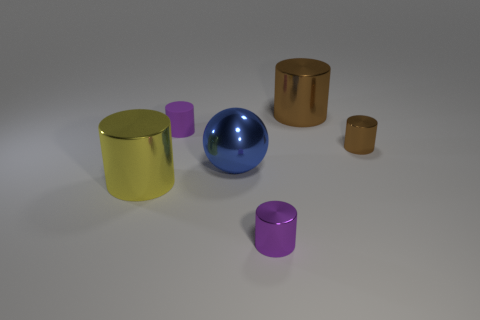Subtract all purple shiny cylinders. How many cylinders are left? 4 Subtract all yellow cylinders. How many cylinders are left? 4 Subtract all green cylinders. Subtract all brown cubes. How many cylinders are left? 5 Add 4 small blue metal blocks. How many objects exist? 10 Subtract all spheres. How many objects are left? 5 Add 1 yellow things. How many yellow things are left? 2 Add 5 small green metal spheres. How many small green metal spheres exist? 5 Subtract 0 purple spheres. How many objects are left? 6 Subtract all large blue metal cylinders. Subtract all big yellow things. How many objects are left? 5 